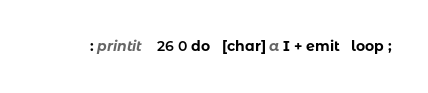Convert code to text. <code><loc_0><loc_0><loc_500><loc_500><_Forth_>: printit    26 0 do   [char] a I + emit   loop ;
</code> 